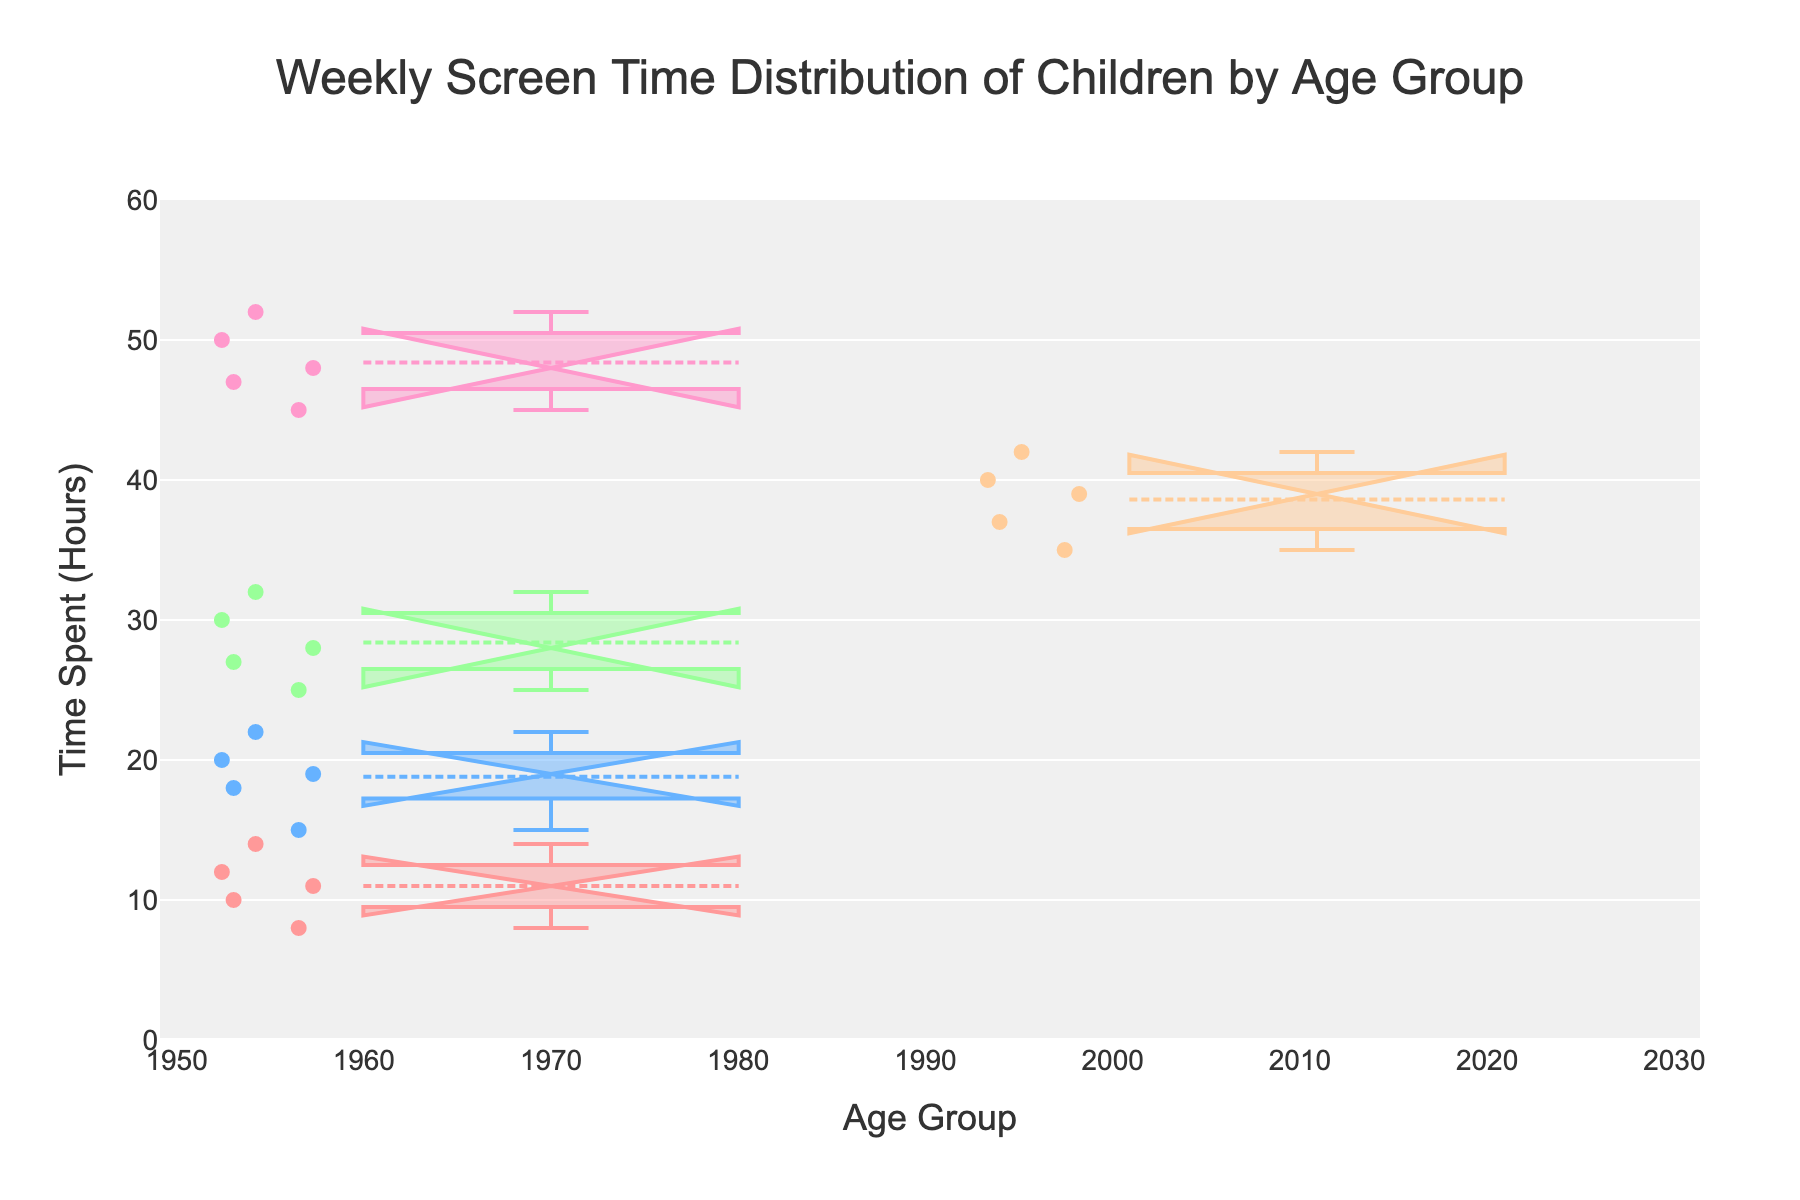What is the title of the figure? The title is displayed at the top of the figure and helps to understand what the figure is about.
Answer: Weekly Screen Time Distribution of Children by Age Group What is the range of the y-axis? The range of the y-axis is visible along the vertical axis of the plot.
Answer: 0 to 60 hours What color represents the age group 10-12? The color of the box plot for each age group is different and can be found by observing the color associated with each age group label.
Answer: Light orange Which age group has the highest median weekly screen time? The median is the line inside the box of each box plot. Identify the age group with the highest median line.
Answer: 13-15 Which group has the lowest spread in terms of screen time? The spread of values in each group can be seen by the width of the box and whiskers. Compare the widths to identify the group with the lowest spread.
Answer: 2-3 What is the median weekly screen time for the 4-6 age group? Locate the median line within the box for the 4-6 age group.
Answer: 19 hours How many age groups have a median screen time above 30 hours? Identify the median (center line) of each age group's box plot and count how many are above 30 hours.
Answer: 3 (7-9, 10-12, 13-15) Which age group shows the greatest variability in screen time? Variability can be observed by the height of the box and the length of the whiskers. The group with the tallest box plot and longest whiskers will have the greatest variability.
Answer: 13-15 What is the interquartile range (IQR) for the age group 7-9? The IQR is the range between the first quartile (bottom of the box) and the third quartile (top of the box). Calculate the difference between these values for 7-9.
Answer: 28 - 27 = 3 hours Do any age groups show overlap in their notches? Notches indicate the confidence interval of the median. Overlapping notches between groups can be observed visually.
Answer: Yes, possibly between 4-6 and 7-9 